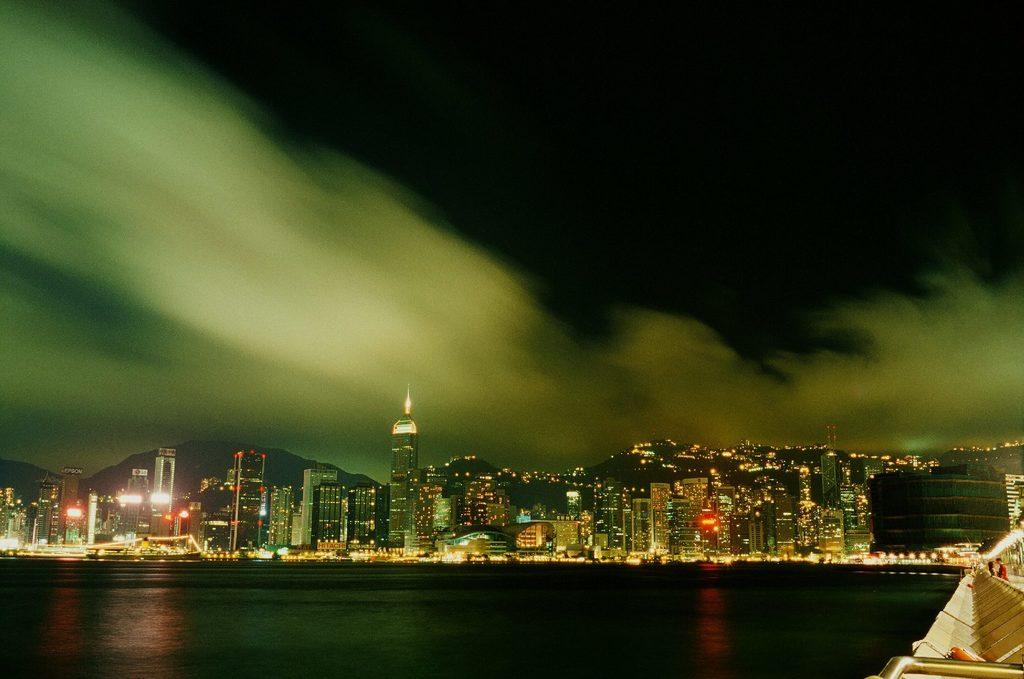What is the primary element in the image? There is water in the image. What can be seen in the background of the image? There are buildings in the background of the image. What else is visible in the image besides the water and buildings? Lights are visible in the image. What is visible at the top of the image? The sky is visible at the top of the image. What type of milk is being used to create the shake in the image? There is no milk or shake present in the image; it features water, buildings, lights, and the sky. 